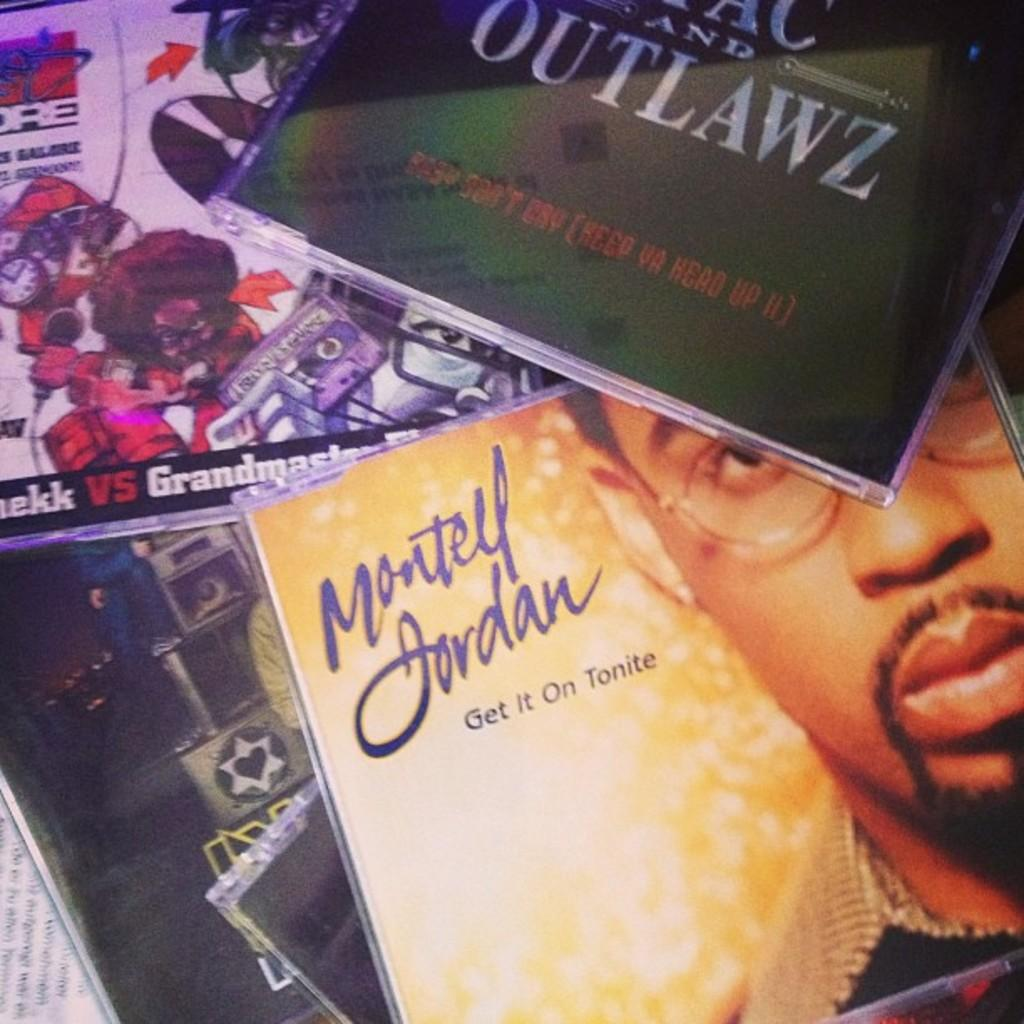<image>
Share a concise interpretation of the image provided. A cd with music by Montell Jordan is in a pile with other music, 